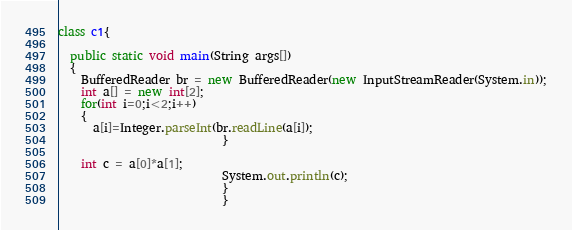Convert code to text. <code><loc_0><loc_0><loc_500><loc_500><_Java_>class c1{
  
  public static void main(String args[])
  {
    BufferedReader br = new BufferedReader(new InputStreamReader(System.in));
    int a[] = new int[2];
    for(int i=0;i<2;i++)
    {
      a[i]=Integer.parseInt(br.readLine(a[i]);
                            }
                            
    int c = a[0]*a[1];
                            System.out.println(c);
                            }
                            }
</code> 